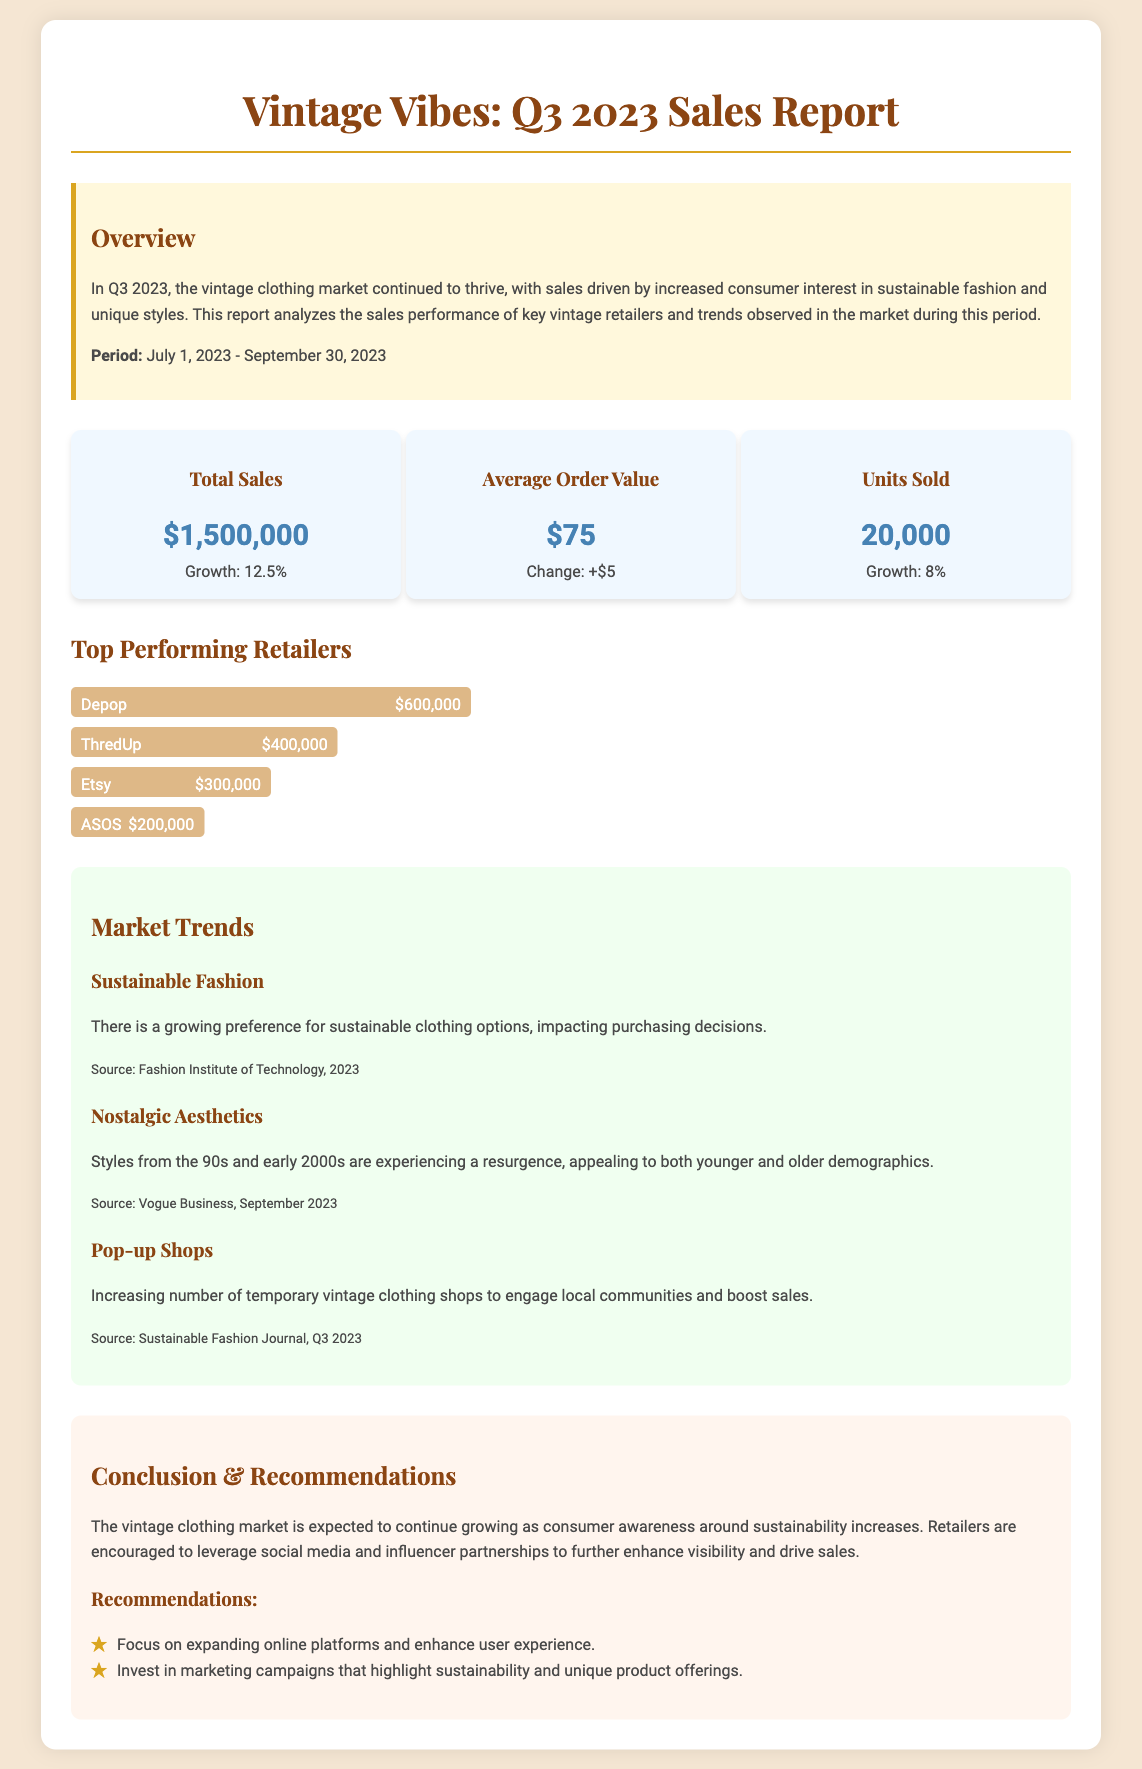What was the total sales in Q3 2023? The total sales figure is provided in the metrics section of the document as $1,500,000.
Answer: $1,500,000 What was the growth percentage of total sales? The growth percentage of total sales is mentioned in the metrics section as 12.5%.
Answer: 12.5% Which retailer had the highest sales? The retailer with the highest sales is shown in the top-performing retailers section as Depop with sales of $600,000.
Answer: Depop What was the average order value in Q3 2023? The average order value is noted in the metrics section as $75.
Answer: $75 What are two trends impacting the vintage clothing market? The document lists multiple trends, two of which are Sustainable Fashion and Nostalgic Aesthetics.
Answer: Sustainable Fashion, Nostalgic Aesthetics What is one recommendation made for retailers? The recommendations section suggests expanding online platforms and enhancing user experience as one strategy.
Answer: Focus on expanding online platforms What is the time period covered in this report? The period covered in the report is specified as July 1, 2023 - September 30, 2023.
Answer: July 1, 2023 - September 30, 2023 How many units were sold in Q3 2023? The total number of units sold is provided in the metrics section as 20,000.
Answer: 20,000 What percentage growth was observed in units sold? The growth in units sold is stated as 8% in the metrics section of the document.
Answer: 8% 